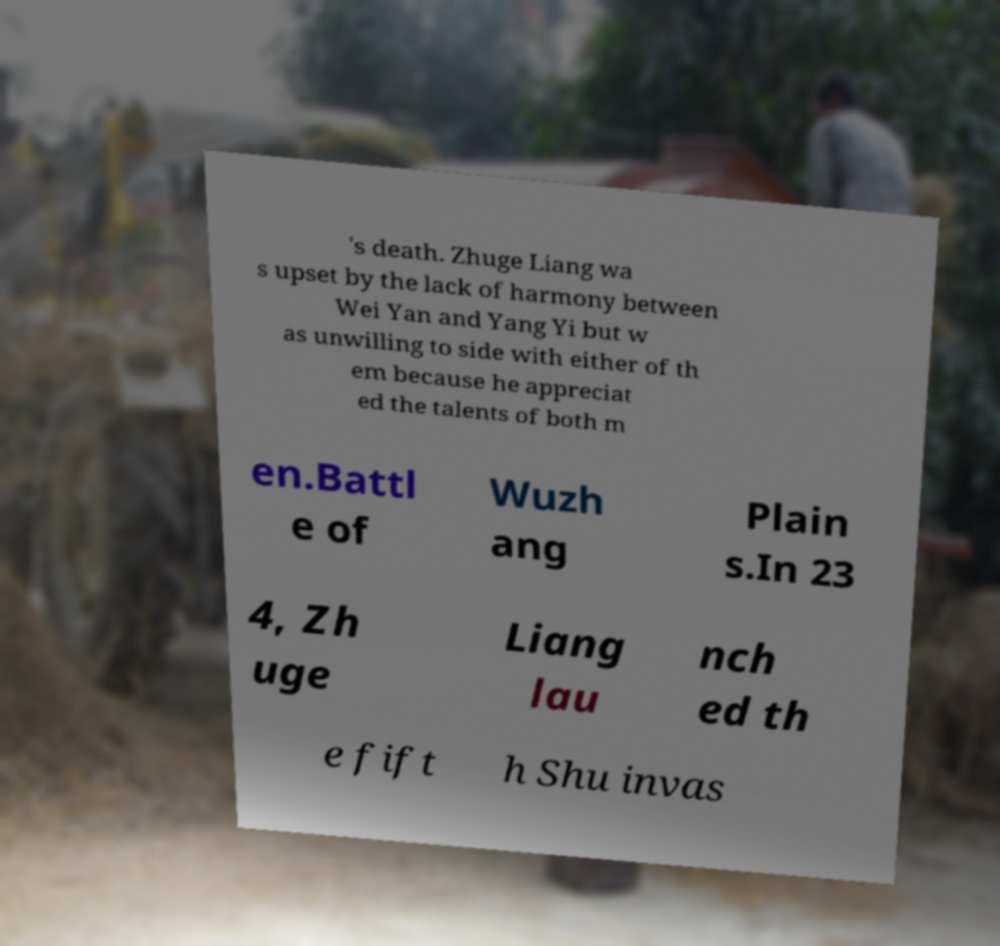Could you assist in decoding the text presented in this image and type it out clearly? 's death. Zhuge Liang wa s upset by the lack of harmony between Wei Yan and Yang Yi but w as unwilling to side with either of th em because he appreciat ed the talents of both m en.Battl e of Wuzh ang Plain s.In 23 4, Zh uge Liang lau nch ed th e fift h Shu invas 